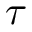<formula> <loc_0><loc_0><loc_500><loc_500>\tau</formula> 